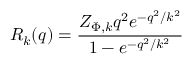<formula> <loc_0><loc_0><loc_500><loc_500>R _ { k } ( q ) = \frac { Z _ { \Phi , k } q ^ { 2 } e ^ { - q ^ { 2 } / k ^ { 2 } } } { 1 - e ^ { - q ^ { 2 } / k ^ { 2 } } }</formula> 